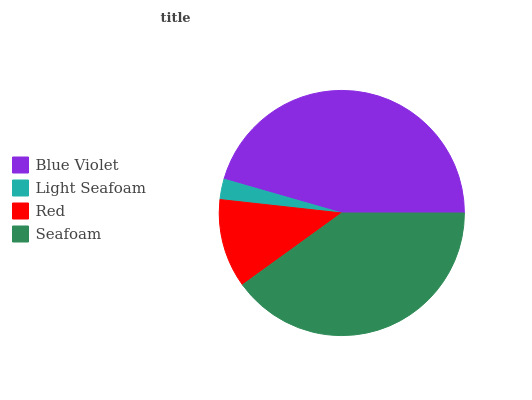Is Light Seafoam the minimum?
Answer yes or no. Yes. Is Blue Violet the maximum?
Answer yes or no. Yes. Is Red the minimum?
Answer yes or no. No. Is Red the maximum?
Answer yes or no. No. Is Red greater than Light Seafoam?
Answer yes or no. Yes. Is Light Seafoam less than Red?
Answer yes or no. Yes. Is Light Seafoam greater than Red?
Answer yes or no. No. Is Red less than Light Seafoam?
Answer yes or no. No. Is Seafoam the high median?
Answer yes or no. Yes. Is Red the low median?
Answer yes or no. Yes. Is Blue Violet the high median?
Answer yes or no. No. Is Seafoam the low median?
Answer yes or no. No. 